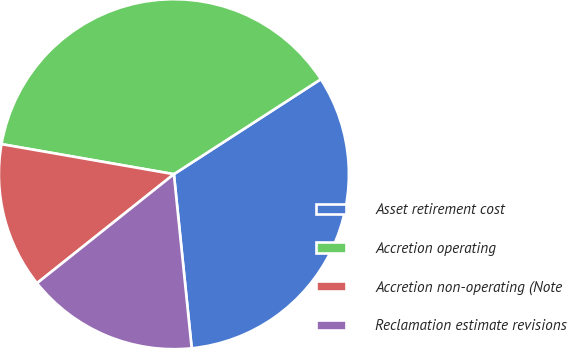Convert chart to OTSL. <chart><loc_0><loc_0><loc_500><loc_500><pie_chart><fcel>Asset retirement cost<fcel>Accretion operating<fcel>Accretion non-operating (Note<fcel>Reclamation estimate revisions<nl><fcel>32.51%<fcel>38.12%<fcel>13.45%<fcel>15.92%<nl></chart> 